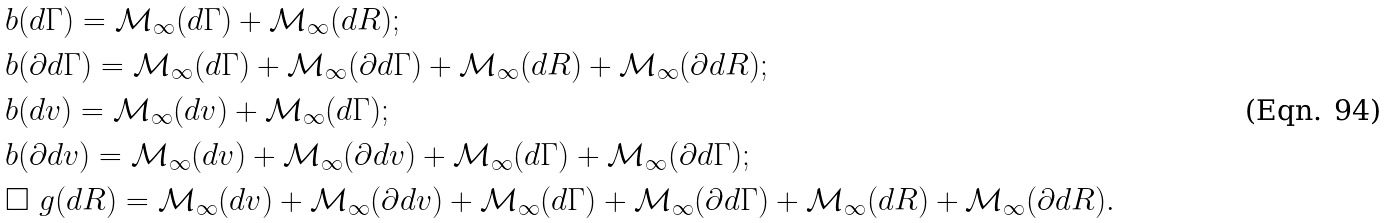Convert formula to latex. <formula><loc_0><loc_0><loc_500><loc_500>& \L b ( d \Gamma ) = \mathcal { M } _ { \infty } ( d \Gamma ) + \mathcal { M } _ { \infty } ( d R ) ; \\ & \L b ( \partial d \Gamma ) = \mathcal { M } _ { \infty } ( d \Gamma ) + \mathcal { M } _ { \infty } ( \partial d \Gamma ) + \mathcal { M } _ { \infty } ( d R ) + \mathcal { M } _ { \infty } ( \partial d R ) ; \\ & \L b ( d v ) = \mathcal { M } _ { \infty } ( d v ) + \mathcal { M } _ { \infty } ( d \Gamma ) ; \\ & \L b ( \partial d v ) = \mathcal { M } _ { \infty } ( d v ) + \mathcal { M } _ { \infty } ( \partial d v ) + \mathcal { M } _ { \infty } ( d \Gamma ) + \mathcal { M } _ { \infty } ( \partial d \Gamma ) ; \\ & \square _ { \ } g ( d R ) = \mathcal { M } _ { \infty } ( d v ) + \mathcal { M } _ { \infty } ( \partial d v ) + \mathcal { M } _ { \infty } ( d \Gamma ) + \mathcal { M } _ { \infty } ( \partial d \Gamma ) + \mathcal { M } _ { \infty } ( d R ) + \mathcal { M } _ { \infty } ( \partial d R ) .</formula> 